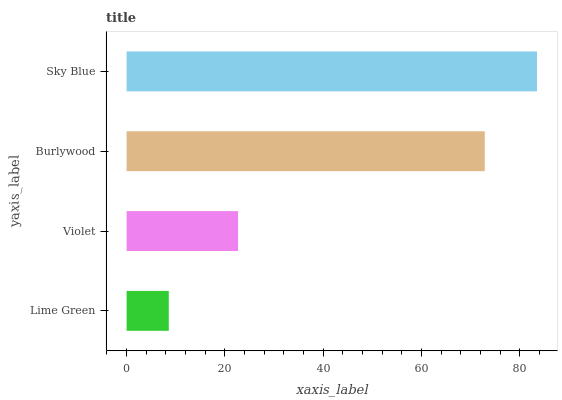Is Lime Green the minimum?
Answer yes or no. Yes. Is Sky Blue the maximum?
Answer yes or no. Yes. Is Violet the minimum?
Answer yes or no. No. Is Violet the maximum?
Answer yes or no. No. Is Violet greater than Lime Green?
Answer yes or no. Yes. Is Lime Green less than Violet?
Answer yes or no. Yes. Is Lime Green greater than Violet?
Answer yes or no. No. Is Violet less than Lime Green?
Answer yes or no. No. Is Burlywood the high median?
Answer yes or no. Yes. Is Violet the low median?
Answer yes or no. Yes. Is Violet the high median?
Answer yes or no. No. Is Lime Green the low median?
Answer yes or no. No. 